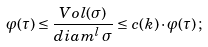Convert formula to latex. <formula><loc_0><loc_0><loc_500><loc_500>\varphi ( \tau ) \leq \frac { V o l ( \sigma ) } { d i a m ^ { l } \, \sigma } \leq c ( k ) \cdot \varphi ( \tau ) \, ;</formula> 